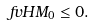<formula> <loc_0><loc_0><loc_500><loc_500>\ f v H { M _ { 0 } } \leq 0 .</formula> 